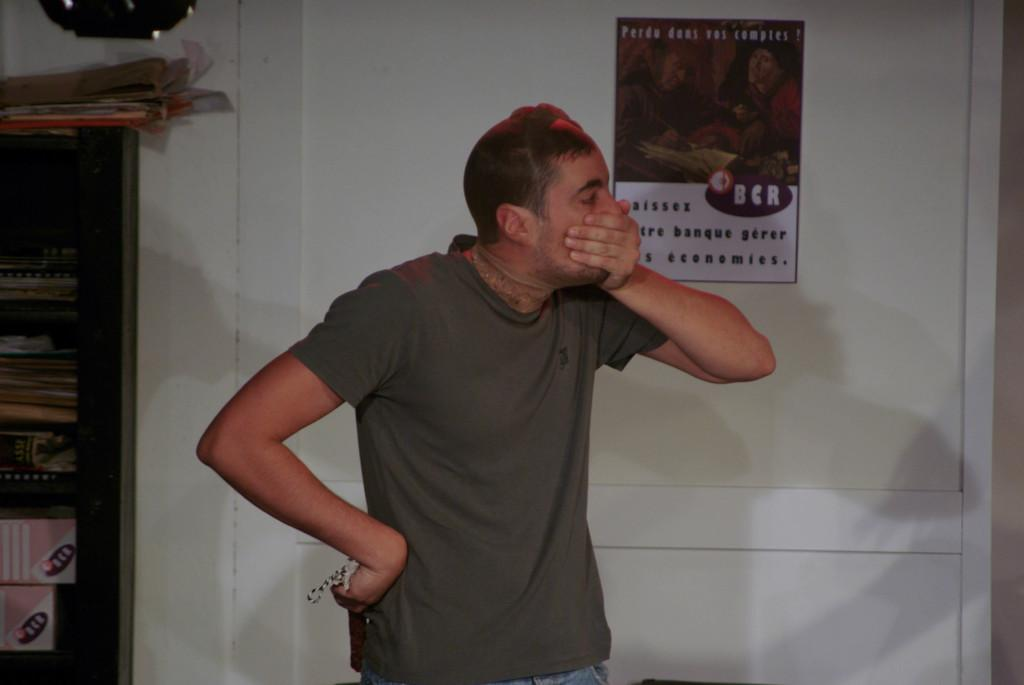<image>
Render a clear and concise summary of the photo. A man standing with his hand over his mouth in front of a sign written in French. 